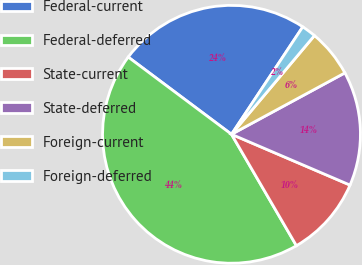Convert chart. <chart><loc_0><loc_0><loc_500><loc_500><pie_chart><fcel>Federal-current<fcel>Federal-deferred<fcel>State-current<fcel>State-deferred<fcel>Foreign-current<fcel>Foreign-deferred<nl><fcel>24.1%<fcel>43.61%<fcel>10.16%<fcel>14.34%<fcel>5.98%<fcel>1.8%<nl></chart> 